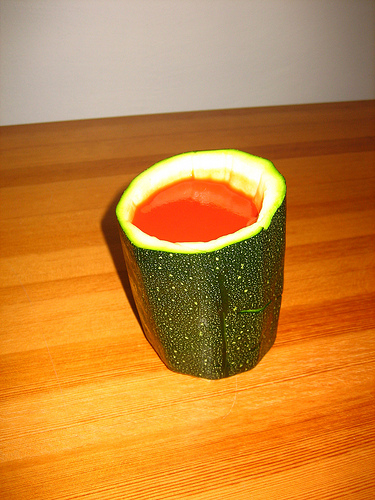<image>
Is there a juice in the vegetable? Yes. The juice is contained within or inside the vegetable, showing a containment relationship. Where is the liquid in relation to the cup? Is it in front of the cup? No. The liquid is not in front of the cup. The spatial positioning shows a different relationship between these objects. 